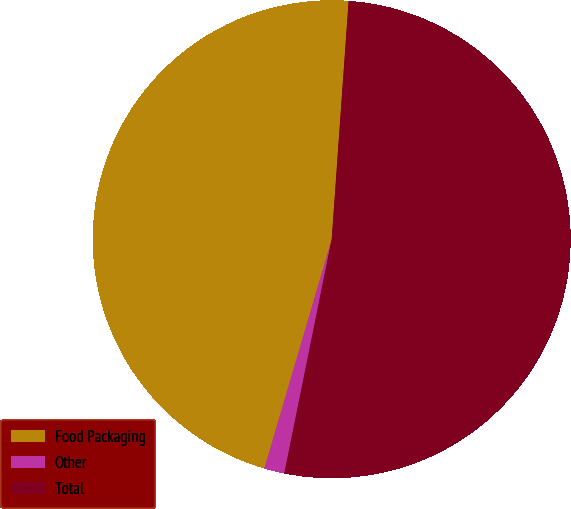Convert chart. <chart><loc_0><loc_0><loc_500><loc_500><pie_chart><fcel>Food Packaging<fcel>Other<fcel>Total<nl><fcel>46.58%<fcel>1.37%<fcel>52.05%<nl></chart> 